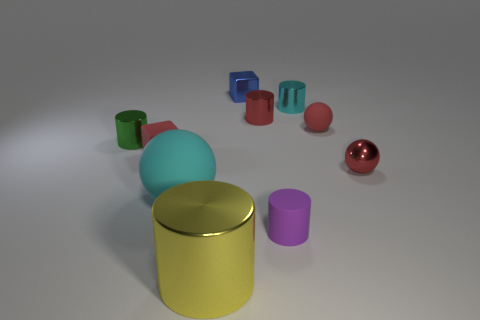What can you tell me about the lighting and shadows visible in the scene? The lighting in the scene is soft and diffused, coming from an angle that is above and to the left of the frame, based on the shadows cast. The shadows are relatively soft-edged, suggesting the light source is not too harsh, creating a calm ambiance. The shadows extend to the right and slightly forward, providing a sense of the three-dimensional arrangement of the objects. 